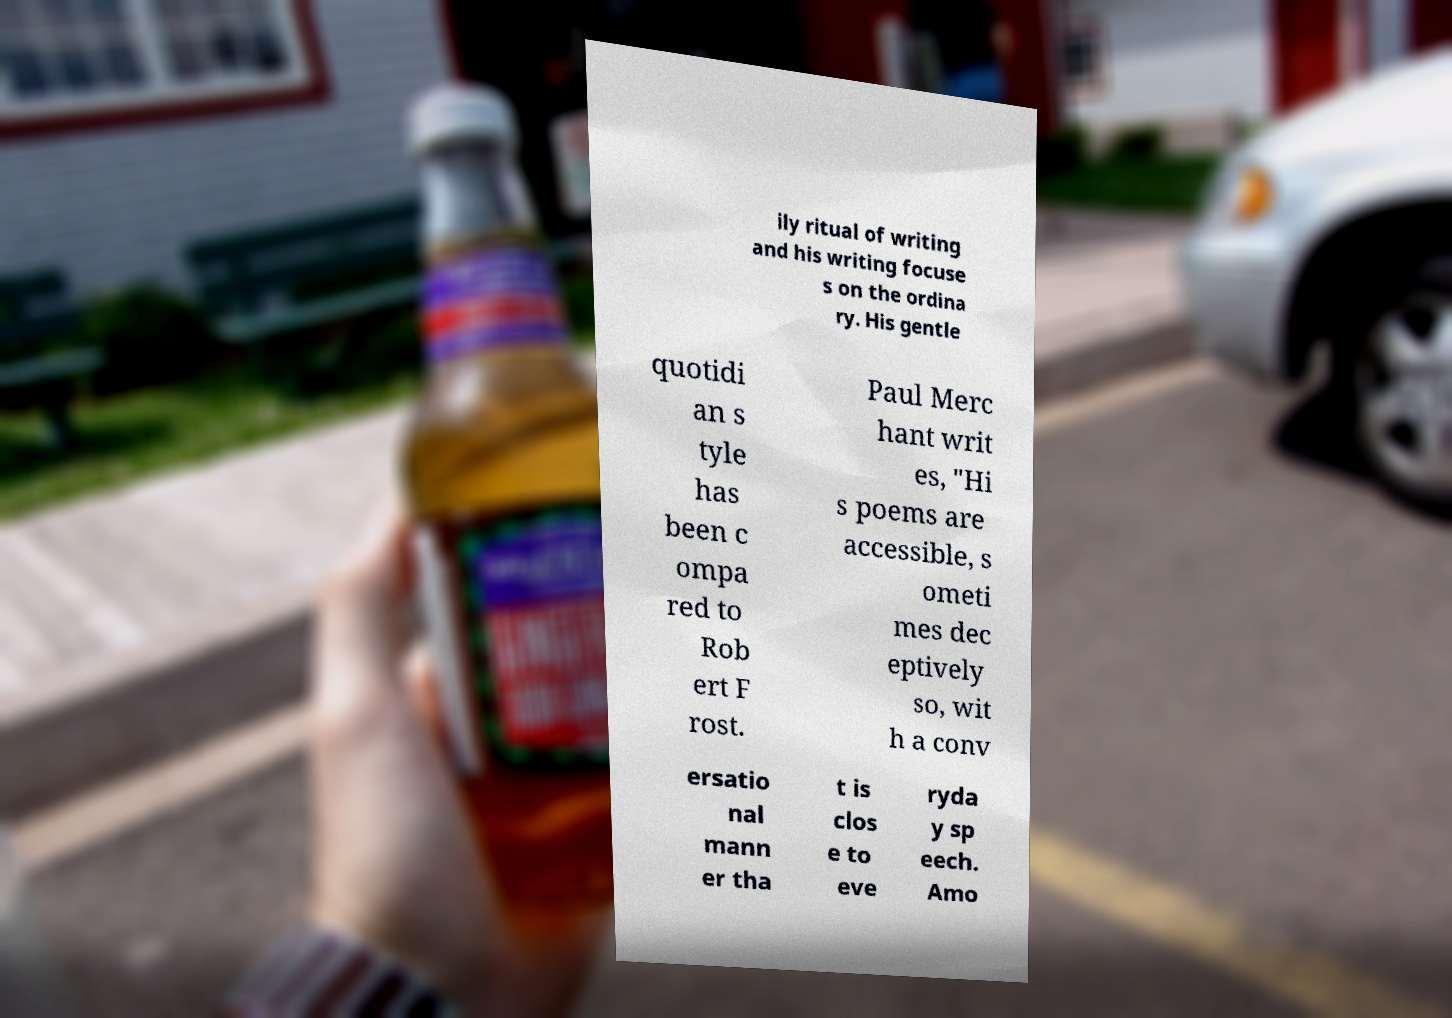Please identify and transcribe the text found in this image. ily ritual of writing and his writing focuse s on the ordina ry. His gentle quotidi an s tyle has been c ompa red to Rob ert F rost. Paul Merc hant writ es, "Hi s poems are accessible, s ometi mes dec eptively so, wit h a conv ersatio nal mann er tha t is clos e to eve ryda y sp eech. Amo 